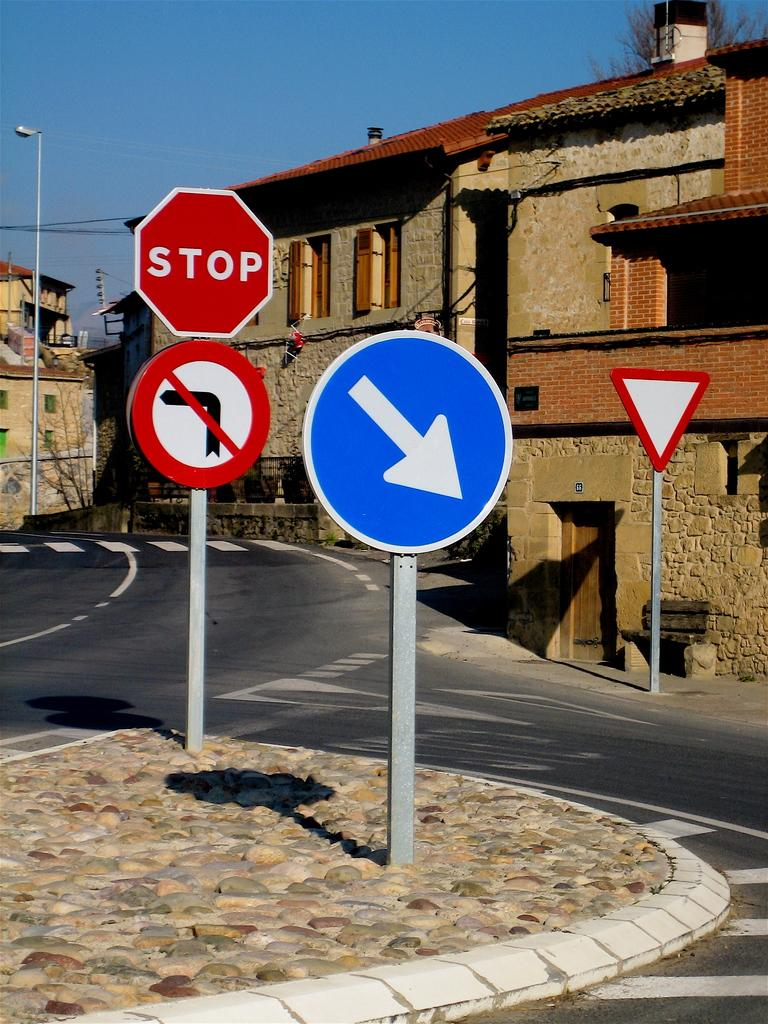Provide a one-sentence caption for the provided image. Different signs that includes a stop sign, yield sign, and down arrow. 